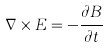<formula> <loc_0><loc_0><loc_500><loc_500>\nabla \times E = - \frac { \partial B } { \partial t }</formula> 